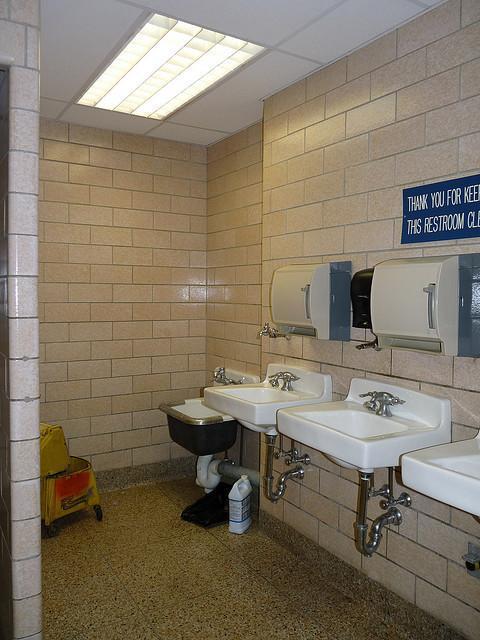How many sinks are there?
Give a very brief answer. 4. 